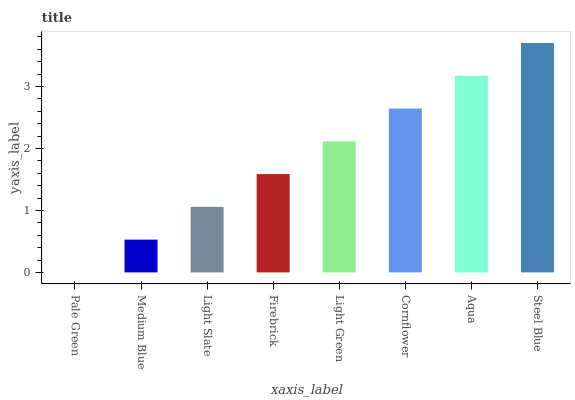Is Pale Green the minimum?
Answer yes or no. Yes. Is Steel Blue the maximum?
Answer yes or no. Yes. Is Medium Blue the minimum?
Answer yes or no. No. Is Medium Blue the maximum?
Answer yes or no. No. Is Medium Blue greater than Pale Green?
Answer yes or no. Yes. Is Pale Green less than Medium Blue?
Answer yes or no. Yes. Is Pale Green greater than Medium Blue?
Answer yes or no. No. Is Medium Blue less than Pale Green?
Answer yes or no. No. Is Light Green the high median?
Answer yes or no. Yes. Is Firebrick the low median?
Answer yes or no. Yes. Is Firebrick the high median?
Answer yes or no. No. Is Cornflower the low median?
Answer yes or no. No. 